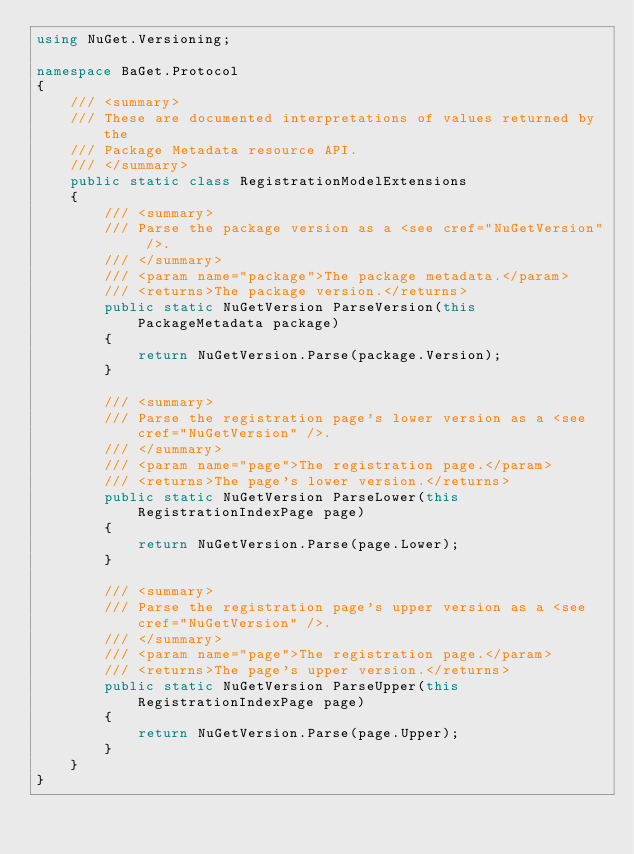Convert code to text. <code><loc_0><loc_0><loc_500><loc_500><_C#_>using NuGet.Versioning;

namespace BaGet.Protocol
{
    /// <summary>
    /// These are documented interpretations of values returned by the
    /// Package Metadata resource API.
    /// </summary>
    public static class RegistrationModelExtensions
    {
        /// <summary>
        /// Parse the package version as a <see cref="NuGetVersion" />.
        /// </summary>
        /// <param name="package">The package metadata.</param>
        /// <returns>The package version.</returns>
        public static NuGetVersion ParseVersion(this PackageMetadata package)
        {
            return NuGetVersion.Parse(package.Version);
        }

        /// <summary>
        /// Parse the registration page's lower version as a <see cref="NuGetVersion" />.
        /// </summary>
        /// <param name="page">The registration page.</param>
        /// <returns>The page's lower version.</returns>
        public static NuGetVersion ParseLower(this RegistrationIndexPage page)
        {
            return NuGetVersion.Parse(page.Lower);
        }

        /// <summary>
        /// Parse the registration page's upper version as a <see cref="NuGetVersion" />.
        /// </summary>
        /// <param name="page">The registration page.</param>
        /// <returns>The page's upper version.</returns>
        public static NuGetVersion ParseUpper(this RegistrationIndexPage page)
        {
            return NuGetVersion.Parse(page.Upper);
        }
    }
}
</code> 